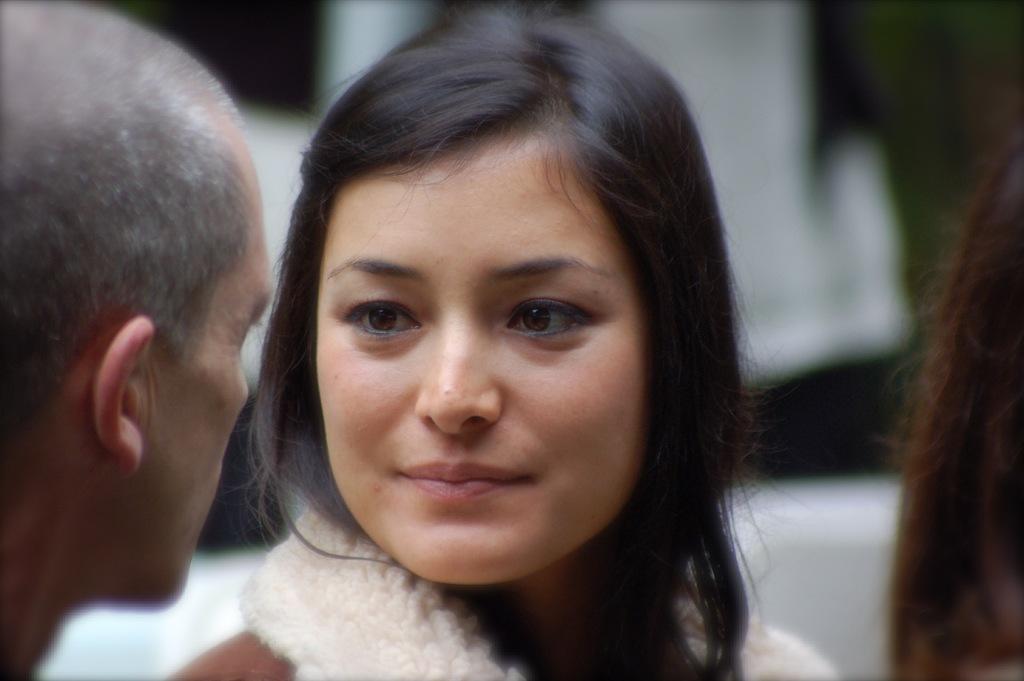Please provide a concise description of this image. In this image, there are two persons looking at each other on the blur background. 